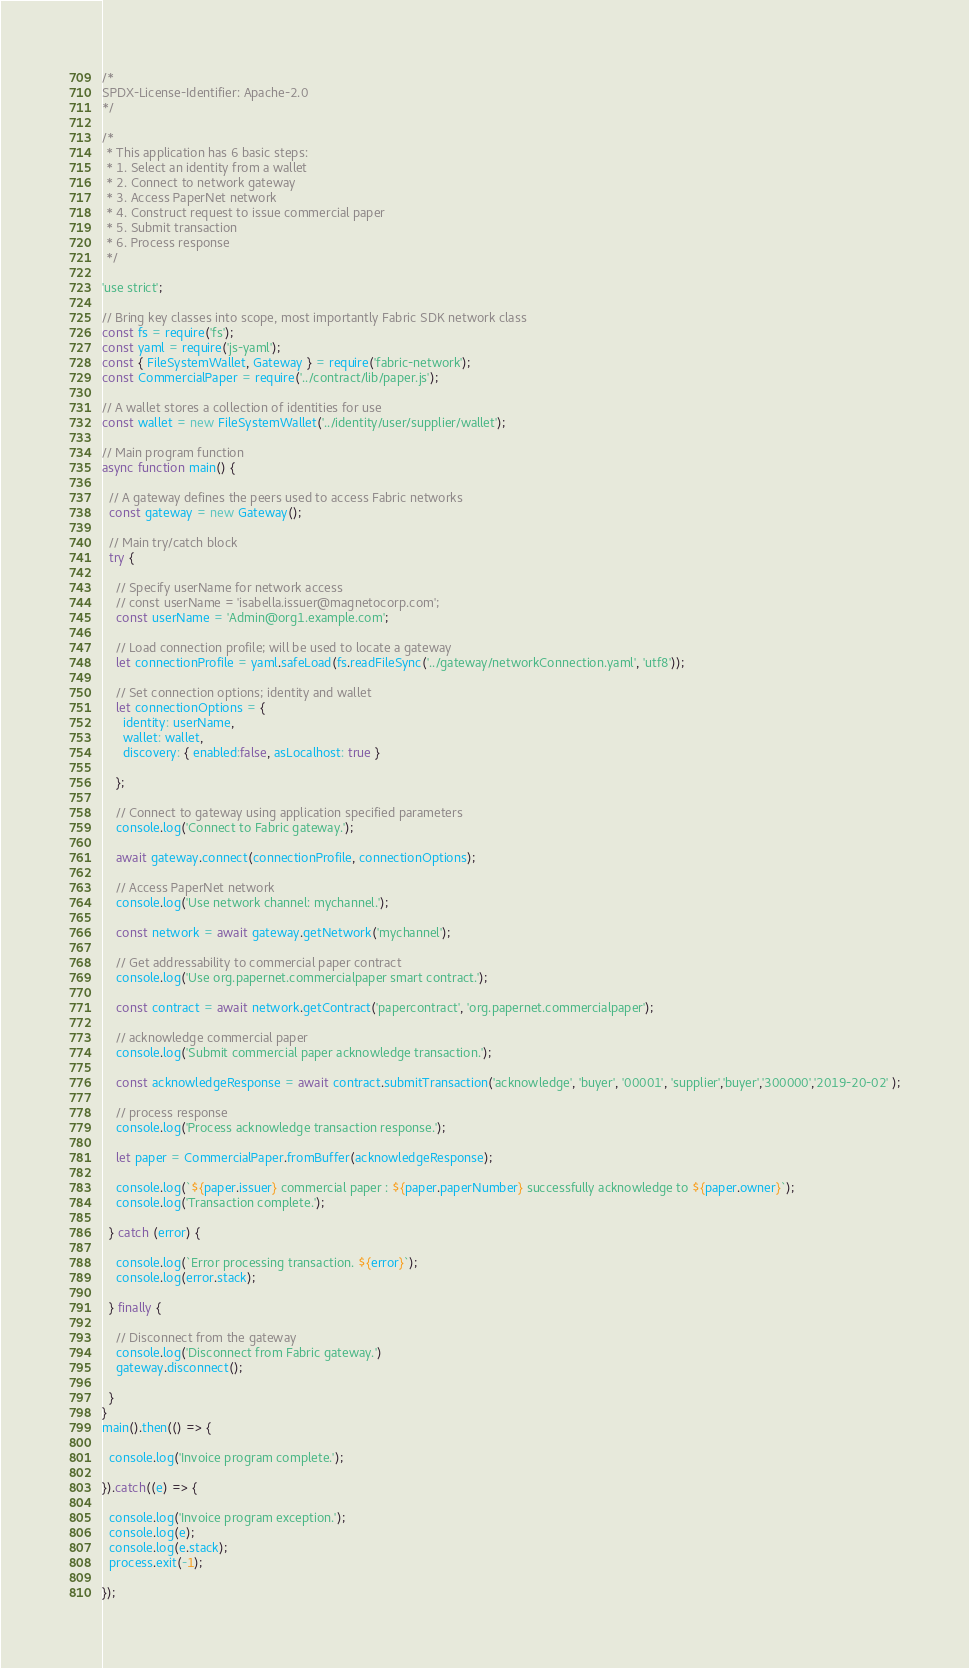<code> <loc_0><loc_0><loc_500><loc_500><_JavaScript_>/*
SPDX-License-Identifier: Apache-2.0
*/

/*
 * This application has 6 basic steps:
 * 1. Select an identity from a wallet
 * 2. Connect to network gateway
 * 3. Access PaperNet network
 * 4. Construct request to issue commercial paper
 * 5. Submit transaction
 * 6. Process response
 */

'use strict';

// Bring key classes into scope, most importantly Fabric SDK network class
const fs = require('fs');
const yaml = require('js-yaml');
const { FileSystemWallet, Gateway } = require('fabric-network');
const CommercialPaper = require('../contract/lib/paper.js');

// A wallet stores a collection of identities for use
const wallet = new FileSystemWallet('../identity/user/supplier/wallet');

// Main program function
async function main() {

  // A gateway defines the peers used to access Fabric networks
  const gateway = new Gateway();

  // Main try/catch block
  try {

    // Specify userName for network access
    // const userName = 'isabella.issuer@magnetocorp.com';
    const userName = 'Admin@org1.example.com';

    // Load connection profile; will be used to locate a gateway
    let connectionProfile = yaml.safeLoad(fs.readFileSync('../gateway/networkConnection.yaml', 'utf8'));

    // Set connection options; identity and wallet
    let connectionOptions = {
      identity: userName,
      wallet: wallet,
      discovery: { enabled:false, asLocalhost: true }

    };

    // Connect to gateway using application specified parameters
    console.log('Connect to Fabric gateway.');

    await gateway.connect(connectionProfile, connectionOptions);

    // Access PaperNet network
    console.log('Use network channel: mychannel.');

    const network = await gateway.getNetwork('mychannel');

    // Get addressability to commercial paper contract
    console.log('Use org.papernet.commercialpaper smart contract.');

    const contract = await network.getContract('papercontract', 'org.papernet.commercialpaper');

    // acknowledge commercial paper
    console.log('Submit commercial paper acknowledge transaction.');

    const acknowledgeResponse = await contract.submitTransaction('acknowledge', 'buyer', '00001', 'supplier','buyer','300000','2019-20-02' );

    // process response
    console.log('Process acknowledge transaction response.');

    let paper = CommercialPaper.fromBuffer(acknowledgeResponse);

    console.log(`${paper.issuer} commercial paper : ${paper.paperNumber} successfully acknowledge to ${paper.owner}`);
    console.log('Transaction complete.');

  } catch (error) {

    console.log(`Error processing transaction. ${error}`);
    console.log(error.stack);

  } finally {

    // Disconnect from the gateway
    console.log('Disconnect from Fabric gateway.')
    gateway.disconnect();

  }
}
main().then(() => {

  console.log('Invoice program complete.');

}).catch((e) => {

  console.log('Invoice program exception.');
  console.log(e);
  console.log(e.stack);
  process.exit(-1);

});</code> 